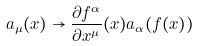<formula> <loc_0><loc_0><loc_500><loc_500>a _ { \mu } ( x ) \to \frac { \partial f ^ { \alpha } } { \partial x ^ { \mu } } ( x ) a _ { \alpha } ( f ( x ) )</formula> 